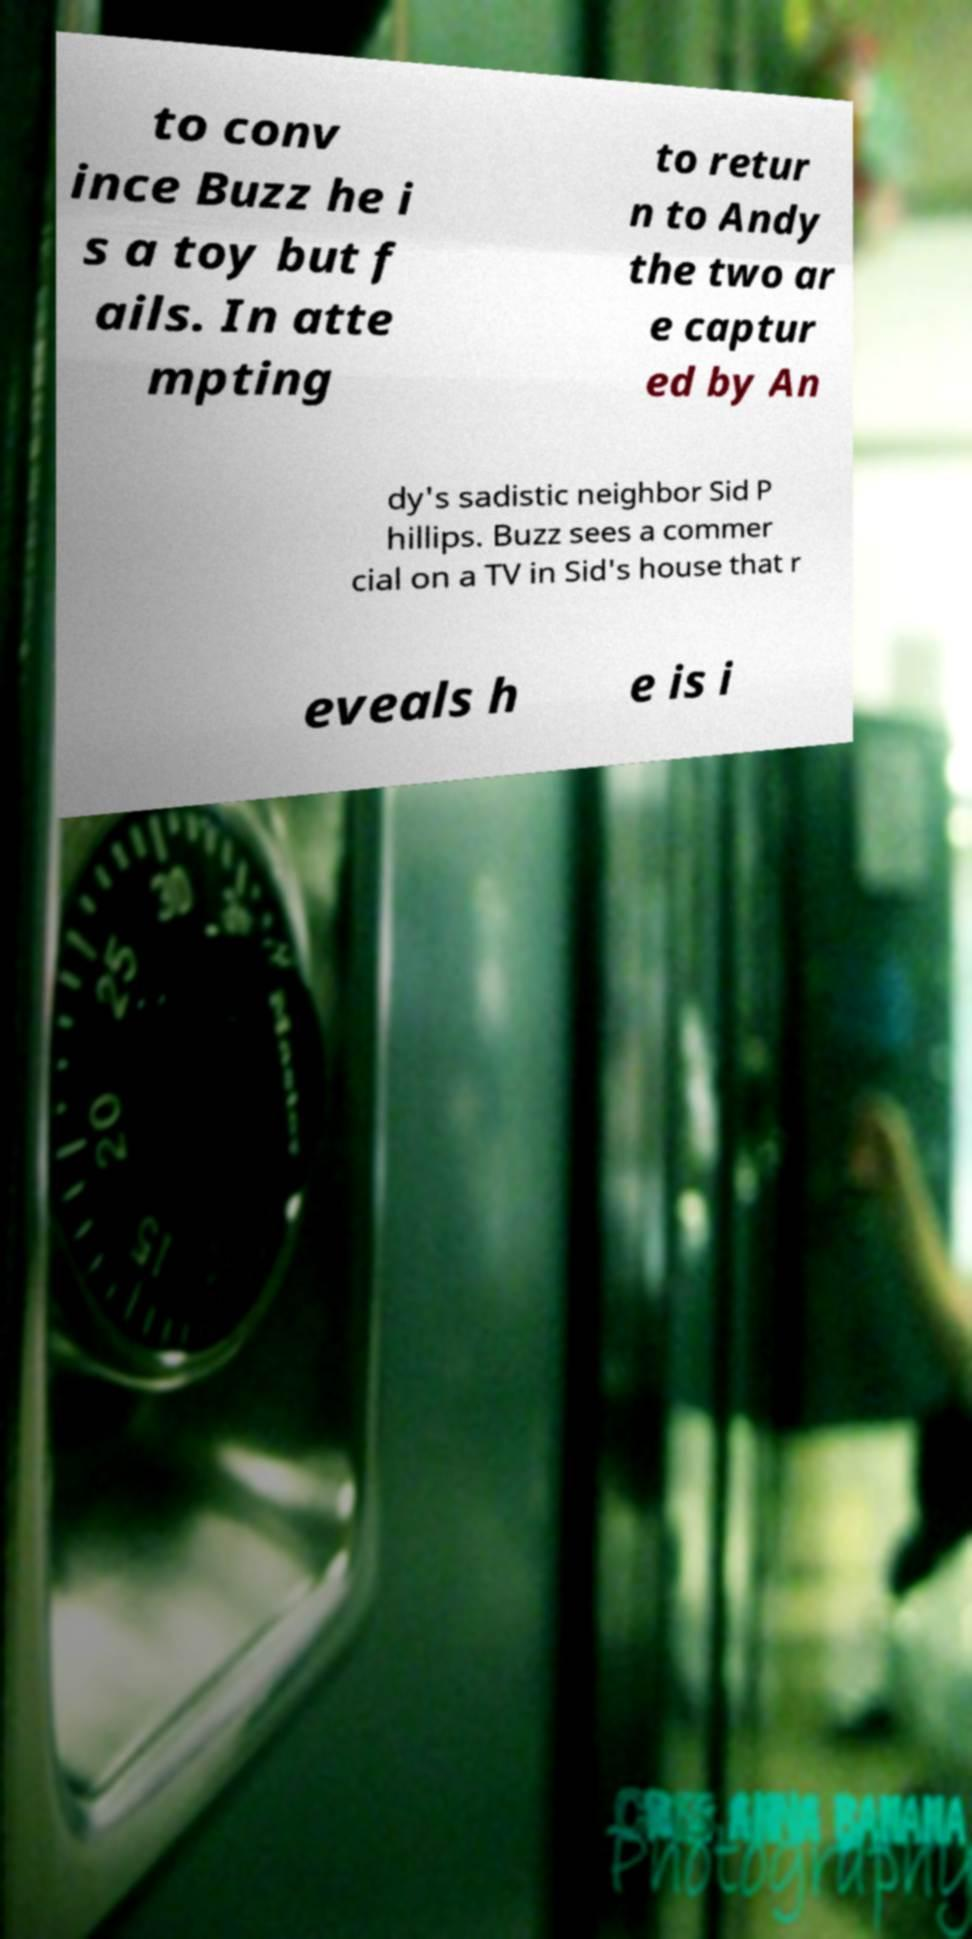For documentation purposes, I need the text within this image transcribed. Could you provide that? to conv ince Buzz he i s a toy but f ails. In atte mpting to retur n to Andy the two ar e captur ed by An dy's sadistic neighbor Sid P hillips. Buzz sees a commer cial on a TV in Sid's house that r eveals h e is i 